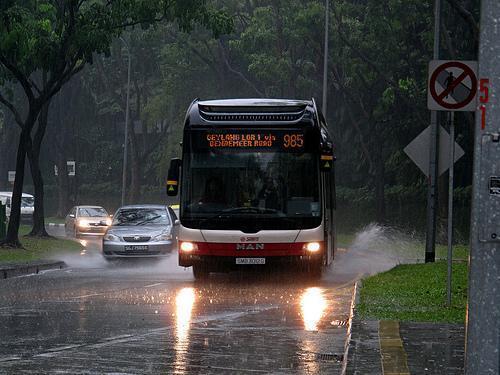How many lights are visible?
Give a very brief answer. 4. How many vehicles are shown?
Give a very brief answer. 4. 